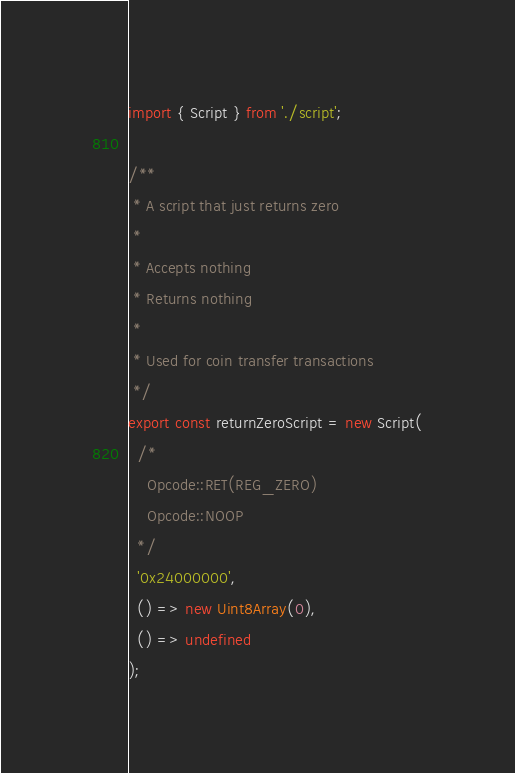Convert code to text. <code><loc_0><loc_0><loc_500><loc_500><_TypeScript_>import { Script } from './script';

/**
 * A script that just returns zero
 *
 * Accepts nothing
 * Returns nothing
 *
 * Used for coin transfer transactions
 */
export const returnZeroScript = new Script(
  /*
    Opcode::RET(REG_ZERO)
    Opcode::NOOP
  */
  '0x24000000',
  () => new Uint8Array(0),
  () => undefined
);
</code> 